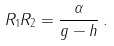Convert formula to latex. <formula><loc_0><loc_0><loc_500><loc_500>R _ { 1 } R _ { 2 } = \frac { \alpha } { g - h } \, .</formula> 